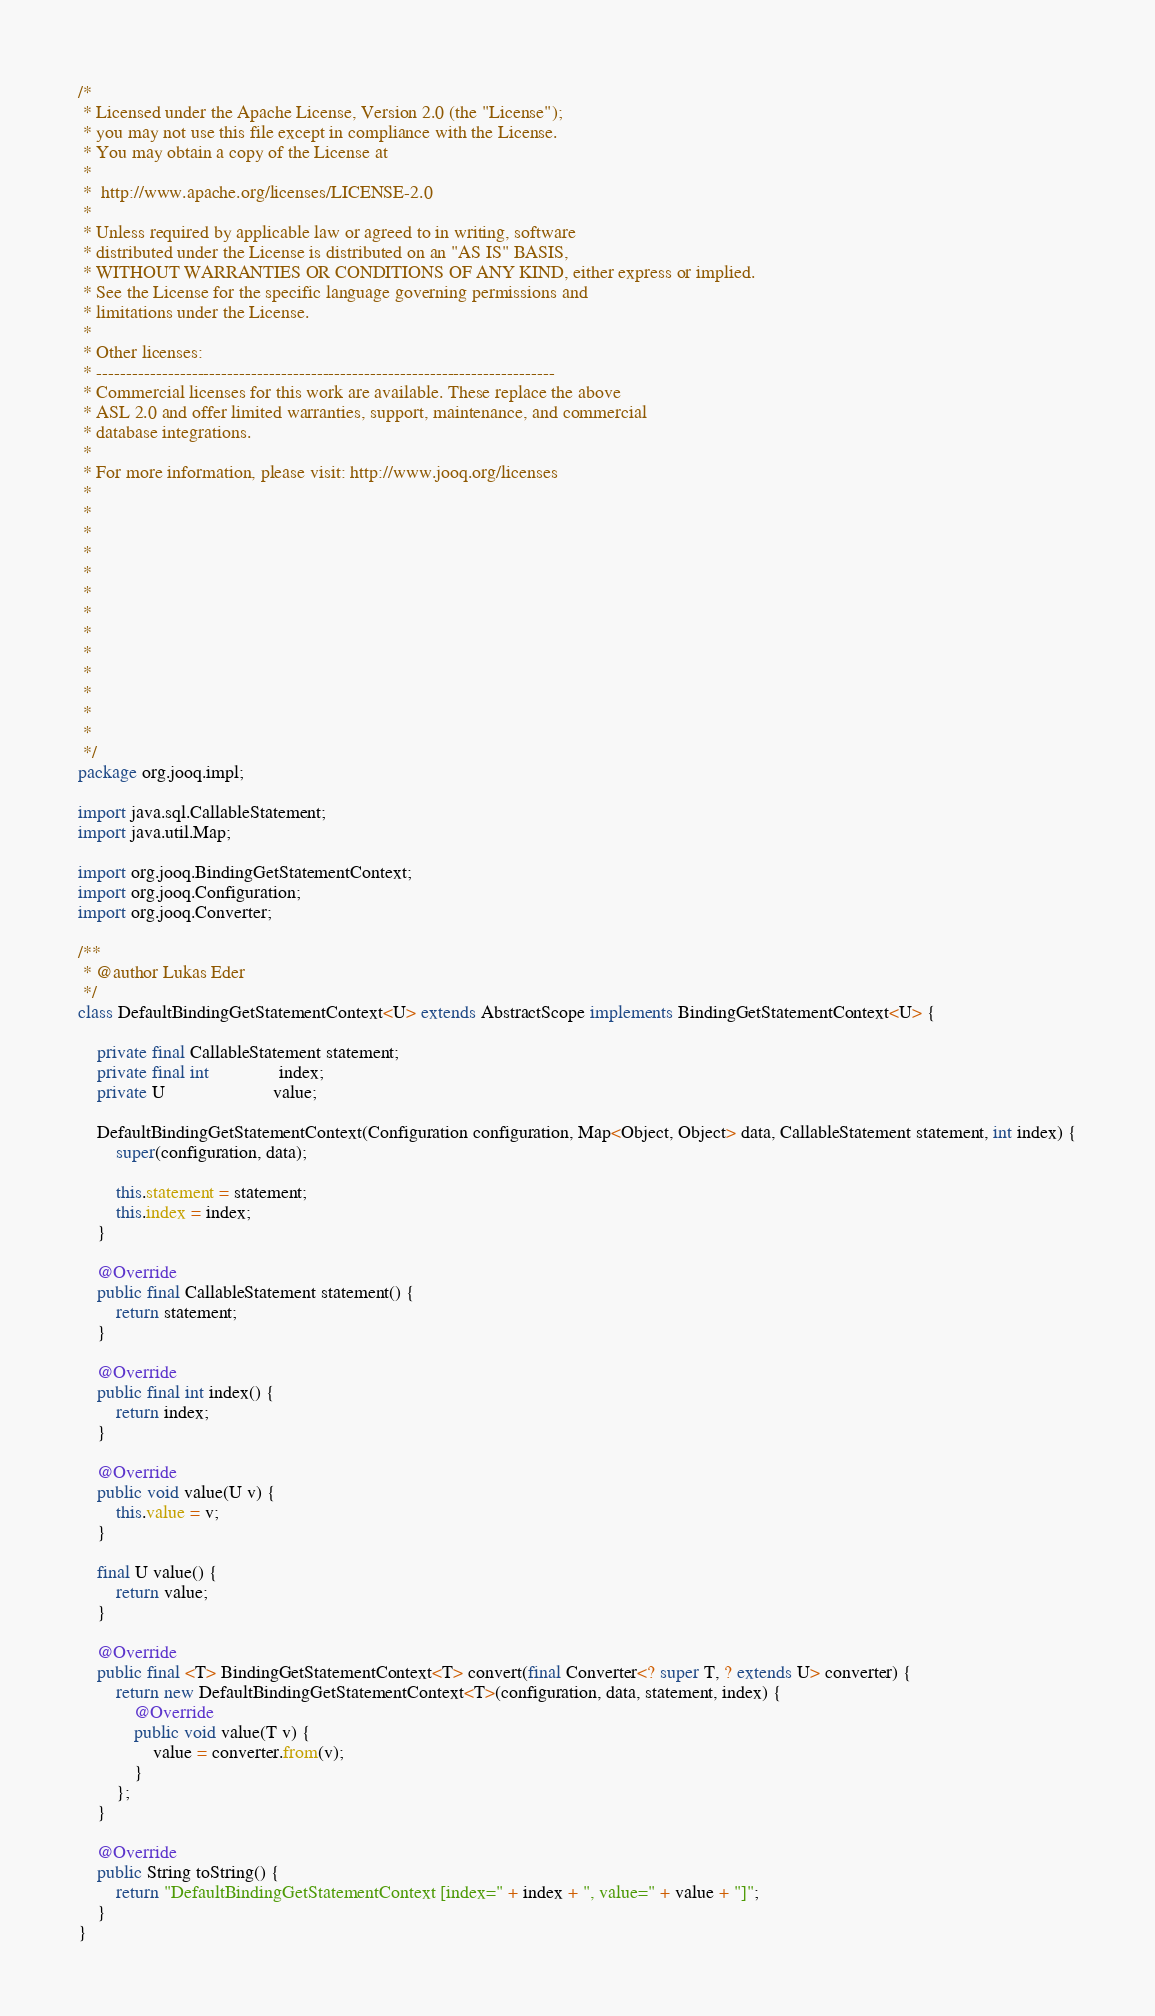Convert code to text. <code><loc_0><loc_0><loc_500><loc_500><_Java_>/*
 * Licensed under the Apache License, Version 2.0 (the "License");
 * you may not use this file except in compliance with the License.
 * You may obtain a copy of the License at
 *
 *  http://www.apache.org/licenses/LICENSE-2.0
 *
 * Unless required by applicable law or agreed to in writing, software
 * distributed under the License is distributed on an "AS IS" BASIS,
 * WITHOUT WARRANTIES OR CONDITIONS OF ANY KIND, either express or implied.
 * See the License for the specific language governing permissions and
 * limitations under the License.
 *
 * Other licenses:
 * -----------------------------------------------------------------------------
 * Commercial licenses for this work are available. These replace the above
 * ASL 2.0 and offer limited warranties, support, maintenance, and commercial
 * database integrations.
 *
 * For more information, please visit: http://www.jooq.org/licenses
 *
 *
 *
 *
 *
 *
 *
 *
 *
 *
 *
 *
 *
 */
package org.jooq.impl;

import java.sql.CallableStatement;
import java.util.Map;

import org.jooq.BindingGetStatementContext;
import org.jooq.Configuration;
import org.jooq.Converter;

/**
 * @author Lukas Eder
 */
class DefaultBindingGetStatementContext<U> extends AbstractScope implements BindingGetStatementContext<U> {

    private final CallableStatement statement;
    private final int               index;
    private U                       value;

    DefaultBindingGetStatementContext(Configuration configuration, Map<Object, Object> data, CallableStatement statement, int index) {
        super(configuration, data);

        this.statement = statement;
        this.index = index;
    }

    @Override
    public final CallableStatement statement() {
        return statement;
    }

    @Override
    public final int index() {
        return index;
    }

    @Override
    public void value(U v) {
        this.value = v;
    }

    final U value() {
        return value;
    }

    @Override
    public final <T> BindingGetStatementContext<T> convert(final Converter<? super T, ? extends U> converter) {
        return new DefaultBindingGetStatementContext<T>(configuration, data, statement, index) {
            @Override
            public void value(T v) {
                value = converter.from(v);
            }
        };
    }

    @Override
    public String toString() {
        return "DefaultBindingGetStatementContext [index=" + index + ", value=" + value + "]";
    }
}
</code> 